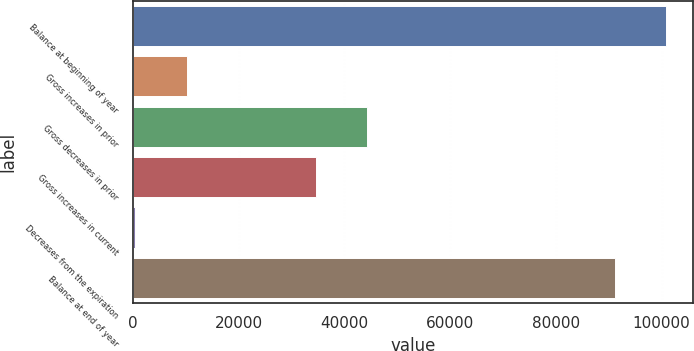Convert chart. <chart><loc_0><loc_0><loc_500><loc_500><bar_chart><fcel>Balance at beginning of year<fcel>Gross increases in prior<fcel>Gross decreases in prior<fcel>Gross increases in current<fcel>Decreases from the expiration<fcel>Balance at end of year<nl><fcel>100846<fcel>10228.5<fcel>44334.5<fcel>34598<fcel>492<fcel>91109<nl></chart> 